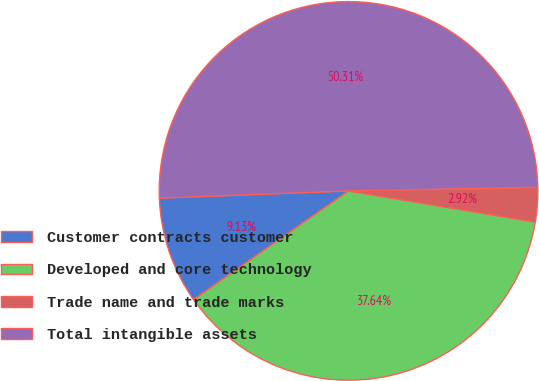Convert chart to OTSL. <chart><loc_0><loc_0><loc_500><loc_500><pie_chart><fcel>Customer contracts customer<fcel>Developed and core technology<fcel>Trade name and trade marks<fcel>Total intangible assets<nl><fcel>9.13%<fcel>37.64%<fcel>2.92%<fcel>50.3%<nl></chart> 